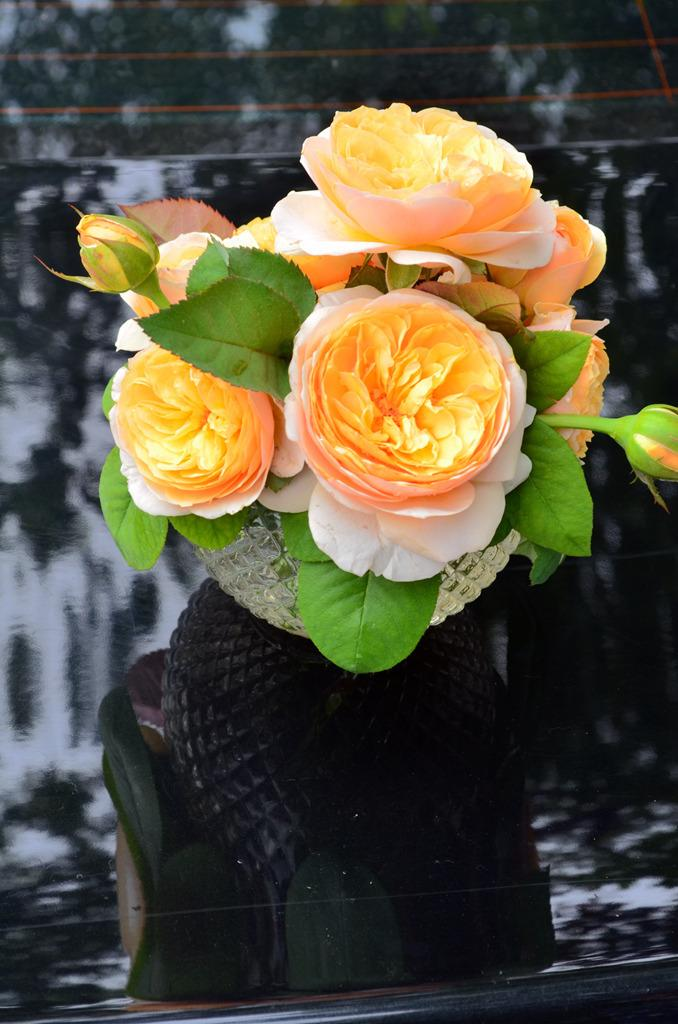What type of plants can be seen in the image? There are flowers and leaves in the image. What can be seen in the background of the image? There are trees in the background of the image. What type of cake is being served on the bridge in the image? There is no cake or bridge present in the image; it features flowers, leaves, and trees. 